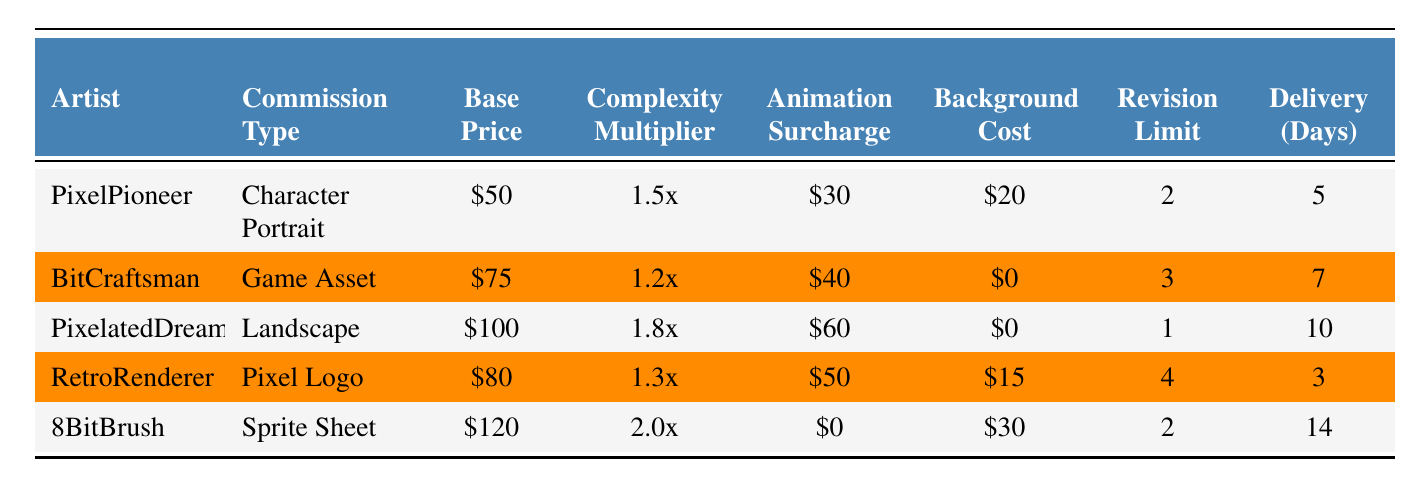What is the base price for a Character Portrait commission? The table lists the commission types and their respective base prices. Under "Character Portrait", the base price is stated as $50.
Answer: $50 Which artist charges the highest delivery time? Looking at the "Delivery (Days)" column, I can see the longest delivery time is 14 days by the artist 8BitBrush for a Sprite Sheet.
Answer: 14 days What is the total cost for a Pixel Logo including animation and background? For the Pixel Logo by RetroRenderer, the base price is $80, the animation surcharge is $50, and the background cost is $15. Summing these gives 80 + 50 + 15 = 145.
Answer: $145 How many artists have a revision limit of 2? Scanning through the "Revision Limit" column, I find that both PixelPioneer and 8BitBrush have a revision limit of 2, making a total of 2 artists.
Answer: 2 artists Is there any commission that includes a background cost of $0? By looking through the "Background Cost" column, I can see that both BitCraftsman and PixelatedDreams list their background cost as $0. Thus, the answer is yes.
Answer: Yes What is the average base price of all the commissions? I will sum the base prices: 50 + 75 + 100 + 80 + 120 = 425. Then, I divide by the 5 commission types, leading to 425 / 5 = 85.
Answer: $85 Which commission type has the highest complexity multiplier? By checking the "Complexity Multiplier" column, I see that the Sprite Sheet from 8BitBrush has the highest multiplier at 2.0x.
Answer: Sprite Sheet If I want to commission an animated Game Asset, what would the total cost be? For a Game Asset by BitCraftsman, the base price is $75, with an animation surcharge of $40 and no background cost. The total is 75 + 40 = 115.
Answer: $115 How many commission types have an animation surcharge over $50? Scanning the "Animation Surcharge" column, I find that PixelatedDreams and RetroRenderer have surcharges above $50, which totals to 2 commission types.
Answer: 2 types Which artist has the quickest delivery time, and what is it? By looking at the "Delivery (Days)" column, I find that RetroRenderer has the quickest delivery time of 3 days for a Pixel Logo.
Answer: 3 days 